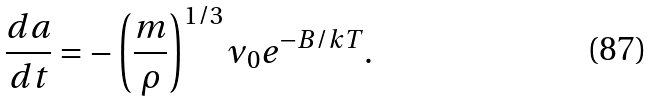<formula> <loc_0><loc_0><loc_500><loc_500>\frac { d a } { d t } = - \left ( \frac { m } { \rho } \right ) ^ { 1 / 3 } \nu _ { 0 } e ^ { - B / k T } .</formula> 